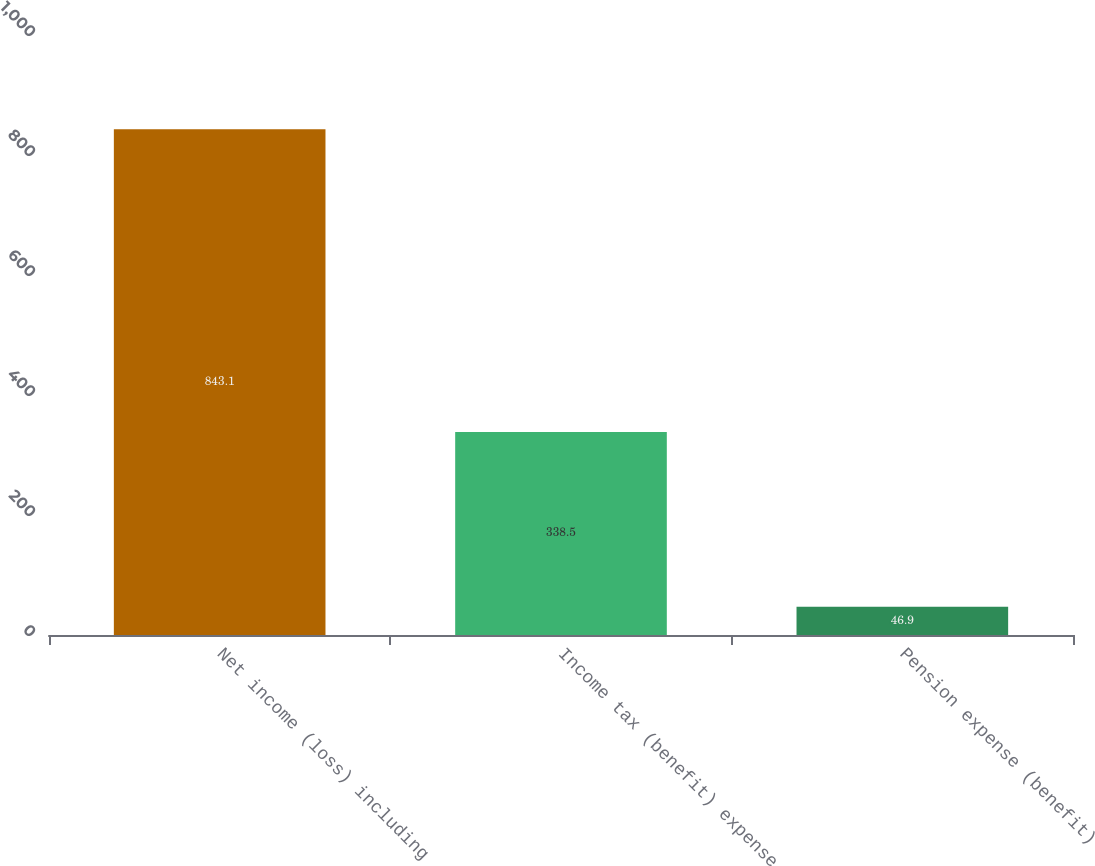Convert chart to OTSL. <chart><loc_0><loc_0><loc_500><loc_500><bar_chart><fcel>Net income (loss) including<fcel>Income tax (benefit) expense<fcel>Pension expense (benefit)<nl><fcel>843.1<fcel>338.5<fcel>46.9<nl></chart> 